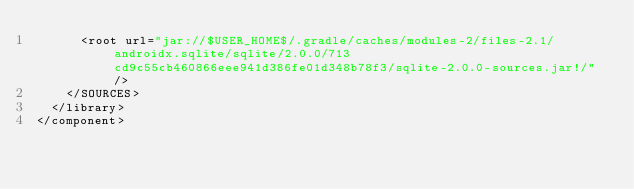<code> <loc_0><loc_0><loc_500><loc_500><_XML_>      <root url="jar://$USER_HOME$/.gradle/caches/modules-2/files-2.1/androidx.sqlite/sqlite/2.0.0/713cd9c55cb460866eee941d386fe01d348b78f3/sqlite-2.0.0-sources.jar!/" />
    </SOURCES>
  </library>
</component></code> 